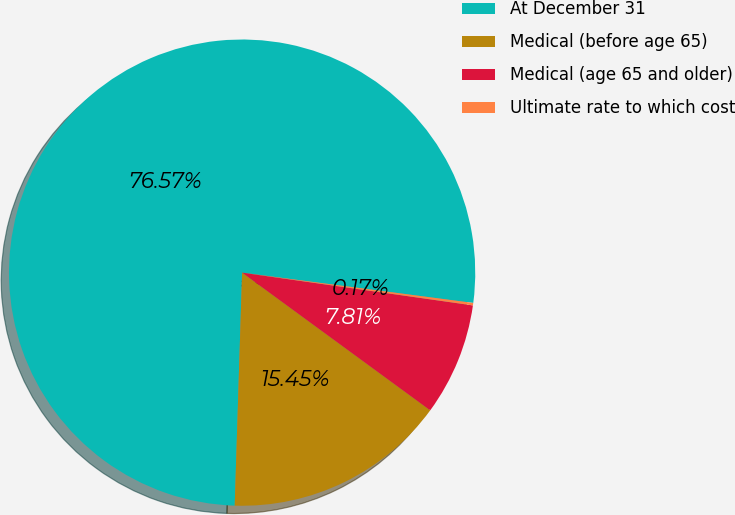Convert chart. <chart><loc_0><loc_0><loc_500><loc_500><pie_chart><fcel>At December 31<fcel>Medical (before age 65)<fcel>Medical (age 65 and older)<fcel>Ultimate rate to which cost<nl><fcel>76.57%<fcel>15.45%<fcel>7.81%<fcel>0.17%<nl></chart> 